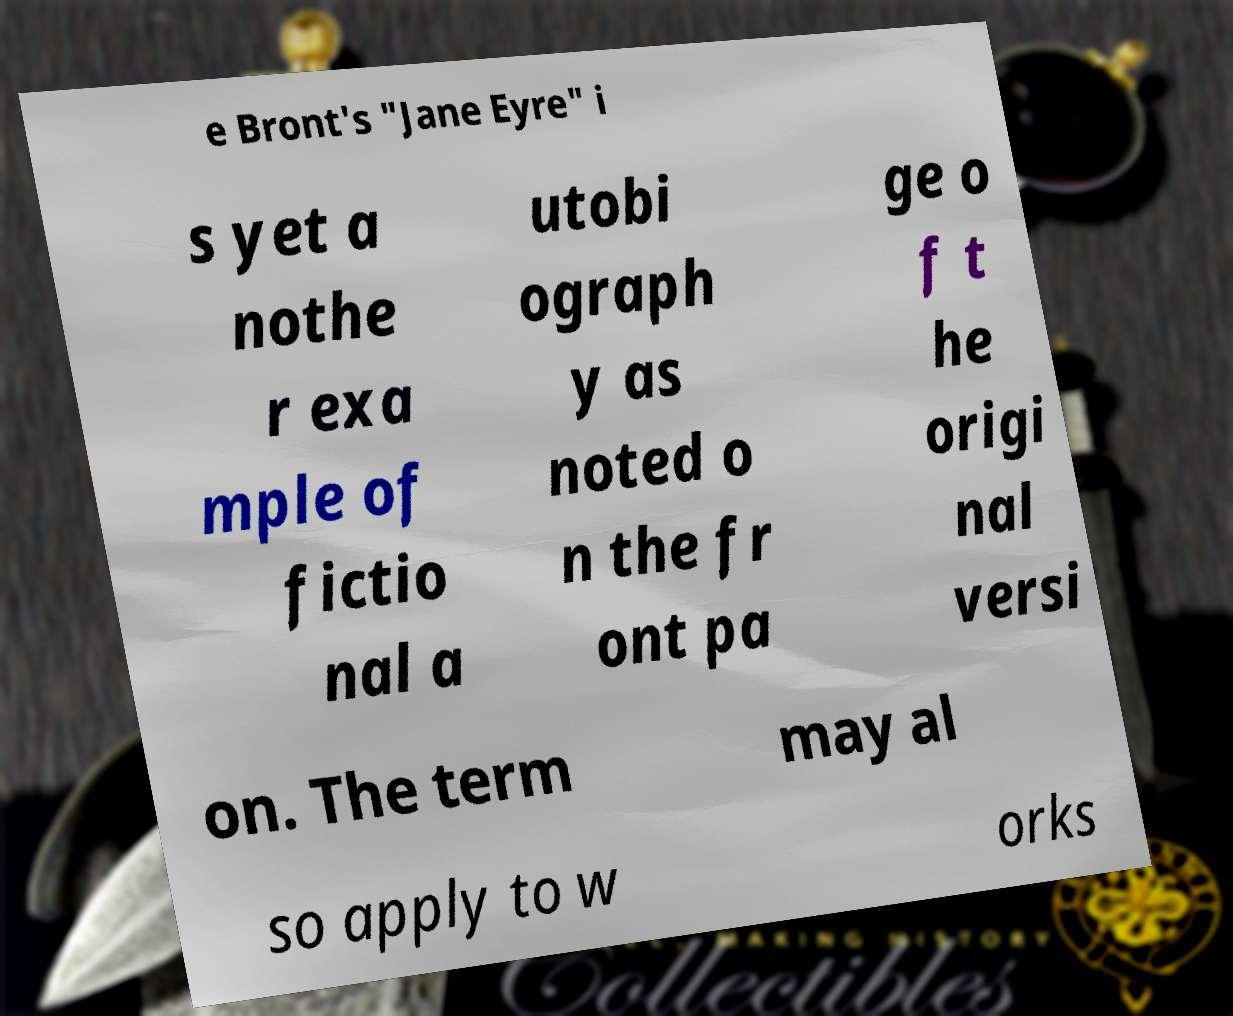For documentation purposes, I need the text within this image transcribed. Could you provide that? e Bront's "Jane Eyre" i s yet a nothe r exa mple of fictio nal a utobi ograph y as noted o n the fr ont pa ge o f t he origi nal versi on. The term may al so apply to w orks 